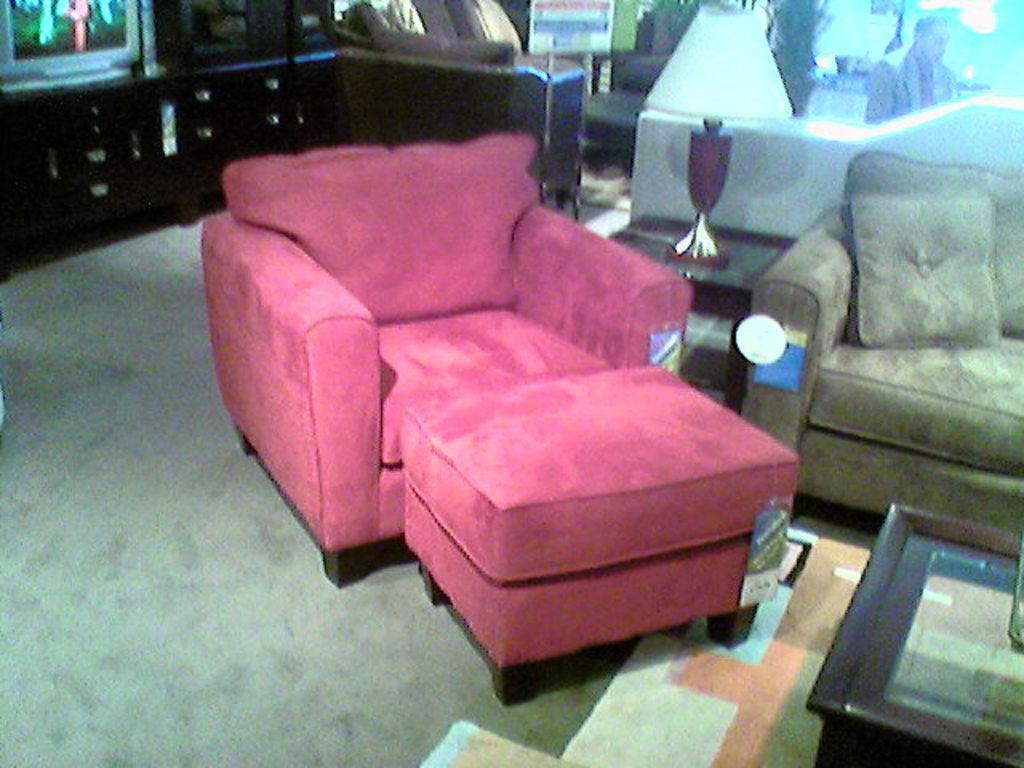Describe this image in one or two sentences. As we can see in the image, there is a television, sofa, lamp and pillow. 